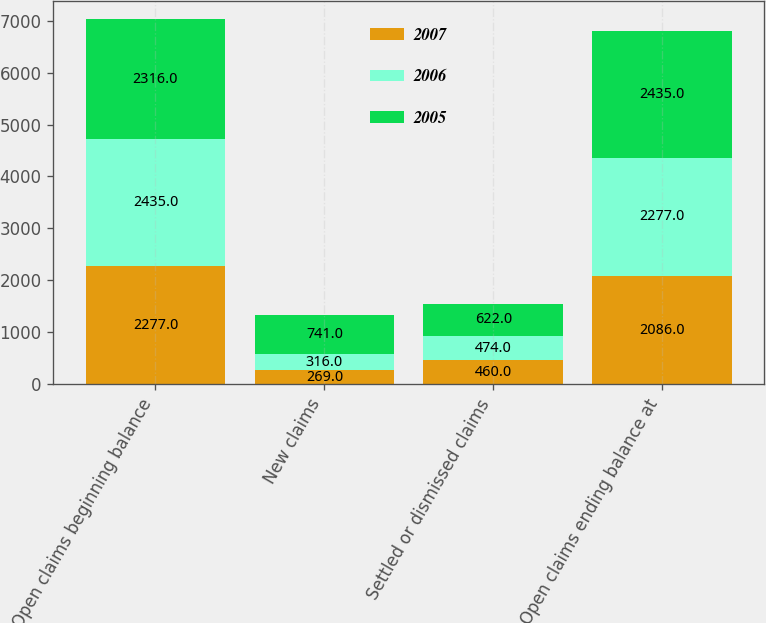<chart> <loc_0><loc_0><loc_500><loc_500><stacked_bar_chart><ecel><fcel>Open claims beginning balance<fcel>New claims<fcel>Settled or dismissed claims<fcel>Open claims ending balance at<nl><fcel>2007<fcel>2277<fcel>269<fcel>460<fcel>2086<nl><fcel>2006<fcel>2435<fcel>316<fcel>474<fcel>2277<nl><fcel>2005<fcel>2316<fcel>741<fcel>622<fcel>2435<nl></chart> 